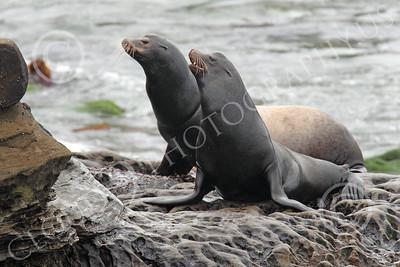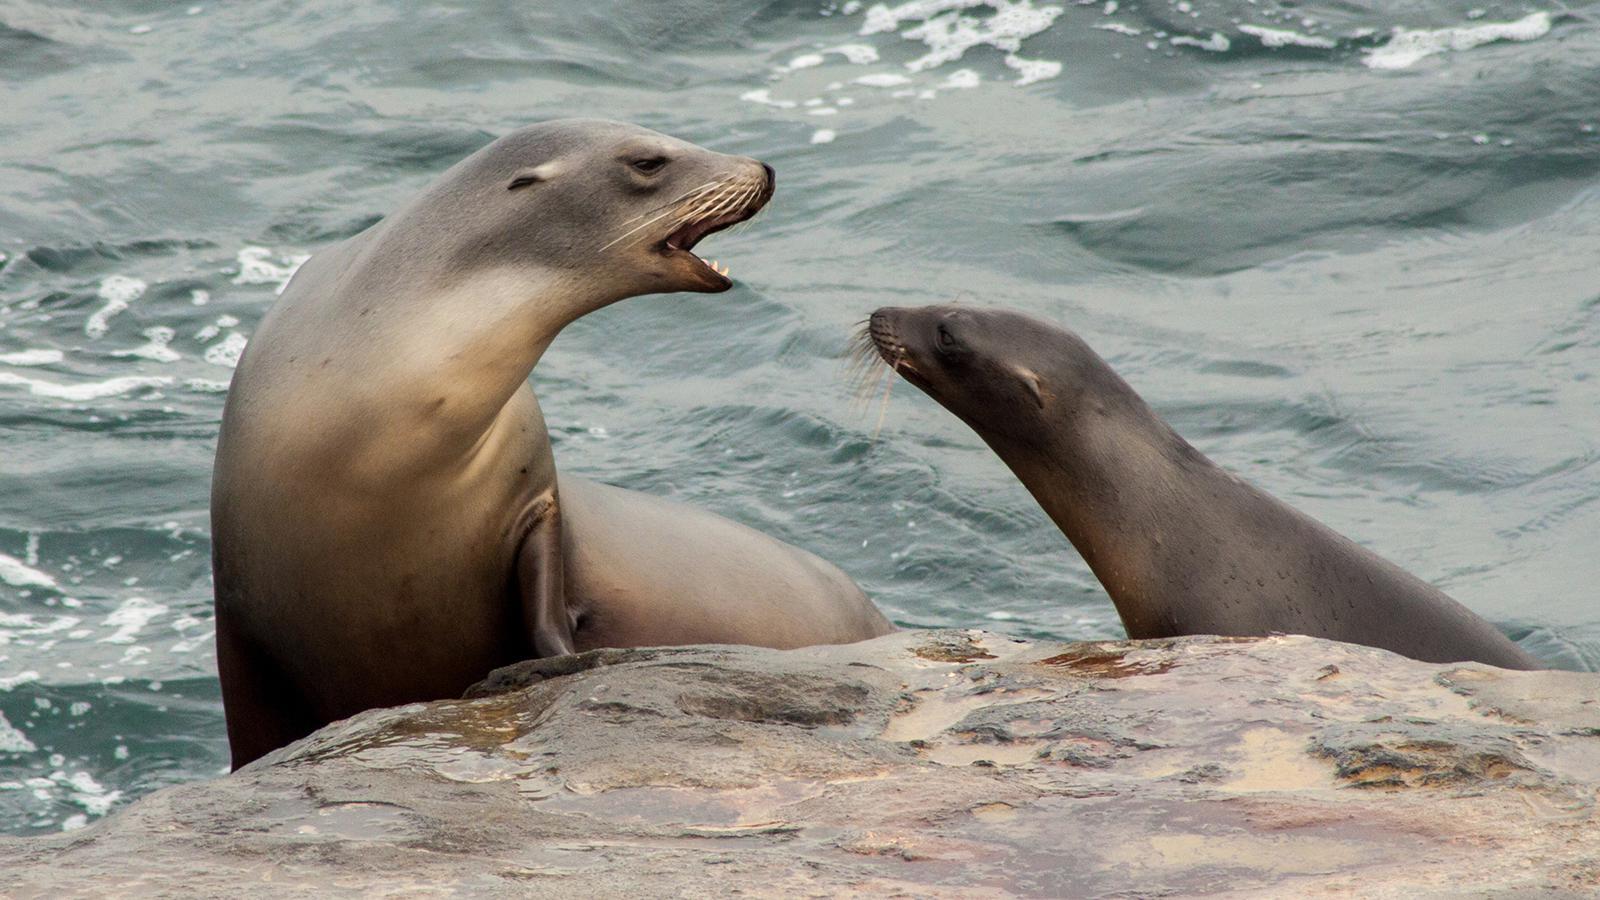The first image is the image on the left, the second image is the image on the right. Analyze the images presented: Is the assertion "The right image contains two seals." valid? Answer yes or no. Yes. 